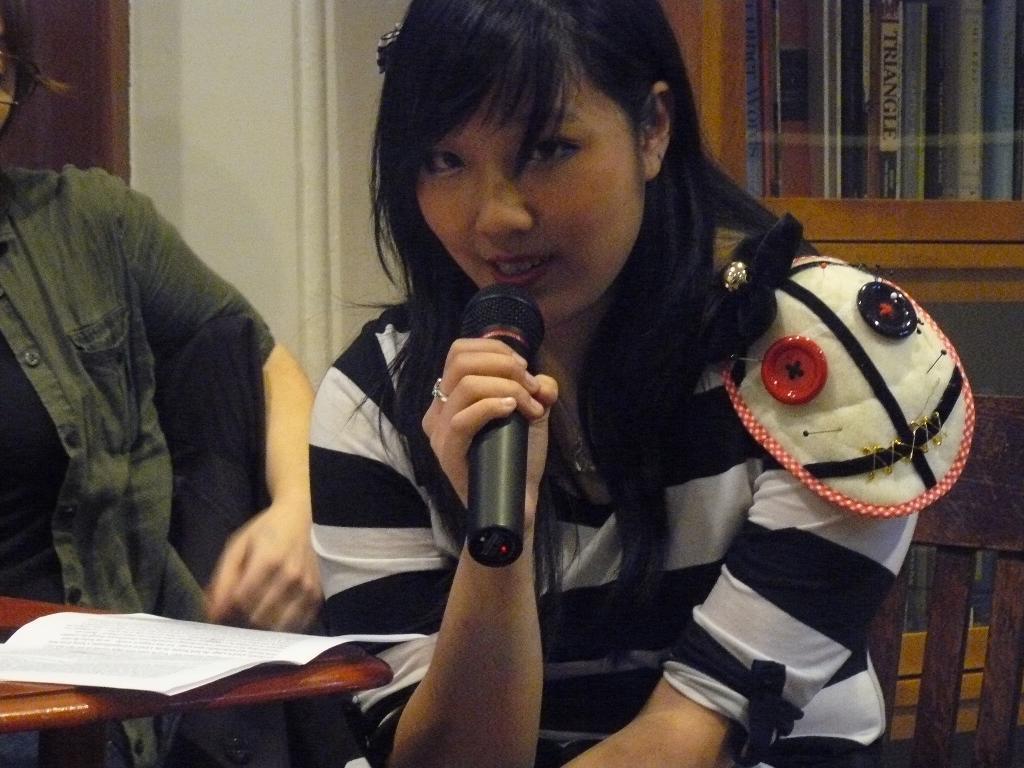How would you summarize this image in a sentence or two? In this image I see a woman who is sitting on a chair and she is holding a mic, I can also see paper over here and there is another person near to her. In the background I see the books in the rack and the wall. 